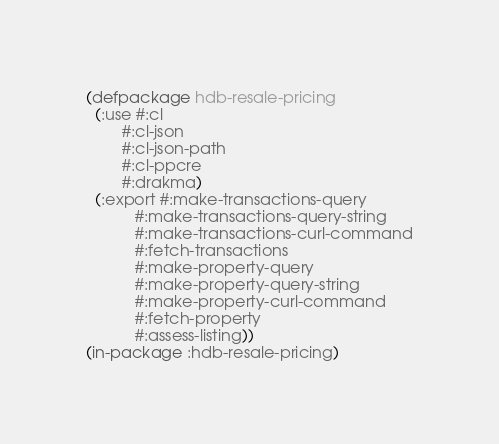<code> <loc_0><loc_0><loc_500><loc_500><_Lisp_>(defpackage hdb-resale-pricing
  (:use #:cl
        #:cl-json
        #:cl-json-path
        #:cl-ppcre
        #:drakma)
  (:export #:make-transactions-query
           #:make-transactions-query-string 
           #:make-transactions-curl-command
           #:fetch-transactions
           #:make-property-query
           #:make-property-query-string
           #:make-property-curl-command
           #:fetch-property
           #:assess-listing))
(in-package :hdb-resale-pricing)
</code> 